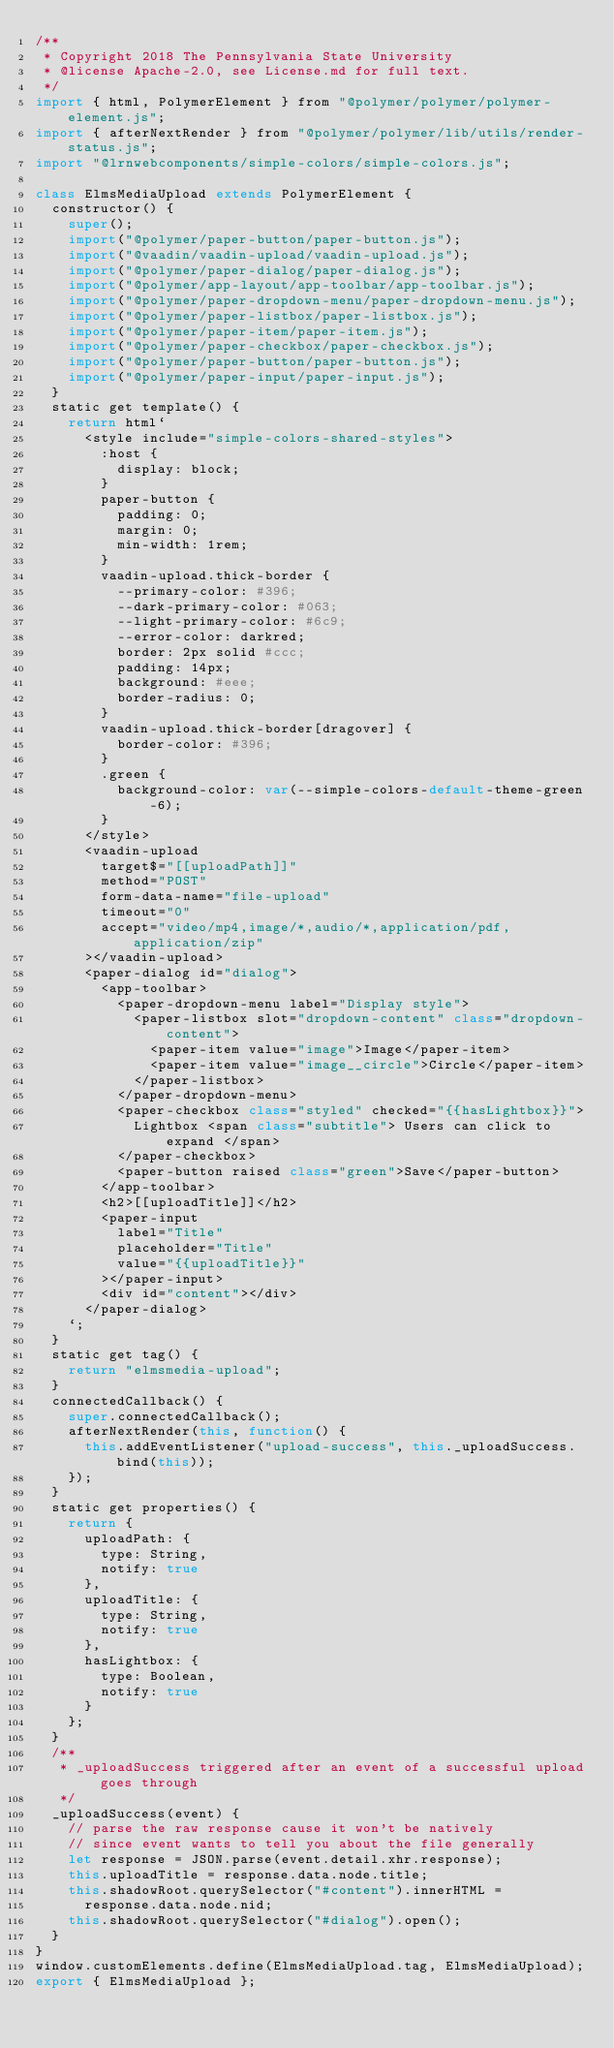<code> <loc_0><loc_0><loc_500><loc_500><_JavaScript_>/**
 * Copyright 2018 The Pennsylvania State University
 * @license Apache-2.0, see License.md for full text.
 */
import { html, PolymerElement } from "@polymer/polymer/polymer-element.js";
import { afterNextRender } from "@polymer/polymer/lib/utils/render-status.js";
import "@lrnwebcomponents/simple-colors/simple-colors.js";

class ElmsMediaUpload extends PolymerElement {
  constructor() {
    super();
    import("@polymer/paper-button/paper-button.js");
    import("@vaadin/vaadin-upload/vaadin-upload.js");
    import("@polymer/paper-dialog/paper-dialog.js");
    import("@polymer/app-layout/app-toolbar/app-toolbar.js");
    import("@polymer/paper-dropdown-menu/paper-dropdown-menu.js");
    import("@polymer/paper-listbox/paper-listbox.js");
    import("@polymer/paper-item/paper-item.js");
    import("@polymer/paper-checkbox/paper-checkbox.js");
    import("@polymer/paper-button/paper-button.js");
    import("@polymer/paper-input/paper-input.js");
  }
  static get template() {
    return html`
      <style include="simple-colors-shared-styles">
        :host {
          display: block;
        }
        paper-button {
          padding: 0;
          margin: 0;
          min-width: 1rem;
        }
        vaadin-upload.thick-border {
          --primary-color: #396;
          --dark-primary-color: #063;
          --light-primary-color: #6c9;
          --error-color: darkred;
          border: 2px solid #ccc;
          padding: 14px;
          background: #eee;
          border-radius: 0;
        }
        vaadin-upload.thick-border[dragover] {
          border-color: #396;
        }
        .green {
          background-color: var(--simple-colors-default-theme-green-6);
        }
      </style>
      <vaadin-upload
        target$="[[uploadPath]]"
        method="POST"
        form-data-name="file-upload"
        timeout="0"
        accept="video/mp4,image/*,audio/*,application/pdf,application/zip"
      ></vaadin-upload>
      <paper-dialog id="dialog">
        <app-toolbar>
          <paper-dropdown-menu label="Display style">
            <paper-listbox slot="dropdown-content" class="dropdown-content">
              <paper-item value="image">Image</paper-item>
              <paper-item value="image__circle">Circle</paper-item>
            </paper-listbox>
          </paper-dropdown-menu>
          <paper-checkbox class="styled" checked="{{hasLightbox}}">
            Lightbox <span class="subtitle"> Users can click to expand </span>
          </paper-checkbox>
          <paper-button raised class="green">Save</paper-button>
        </app-toolbar>
        <h2>[[uploadTitle]]</h2>
        <paper-input
          label="Title"
          placeholder="Title"
          value="{{uploadTitle}}"
        ></paper-input>
        <div id="content"></div>
      </paper-dialog>
    `;
  }
  static get tag() {
    return "elmsmedia-upload";
  }
  connectedCallback() {
    super.connectedCallback();
    afterNextRender(this, function() {
      this.addEventListener("upload-success", this._uploadSuccess.bind(this));
    });
  }
  static get properties() {
    return {
      uploadPath: {
        type: String,
        notify: true
      },
      uploadTitle: {
        type: String,
        notify: true
      },
      hasLightbox: {
        type: Boolean,
        notify: true
      }
    };
  }
  /**
   * _uploadSuccess triggered after an event of a successful upload goes through
   */
  _uploadSuccess(event) {
    // parse the raw response cause it won't be natively
    // since event wants to tell you about the file generally
    let response = JSON.parse(event.detail.xhr.response);
    this.uploadTitle = response.data.node.title;
    this.shadowRoot.querySelector("#content").innerHTML =
      response.data.node.nid;
    this.shadowRoot.querySelector("#dialog").open();
  }
}
window.customElements.define(ElmsMediaUpload.tag, ElmsMediaUpload);
export { ElmsMediaUpload };
</code> 